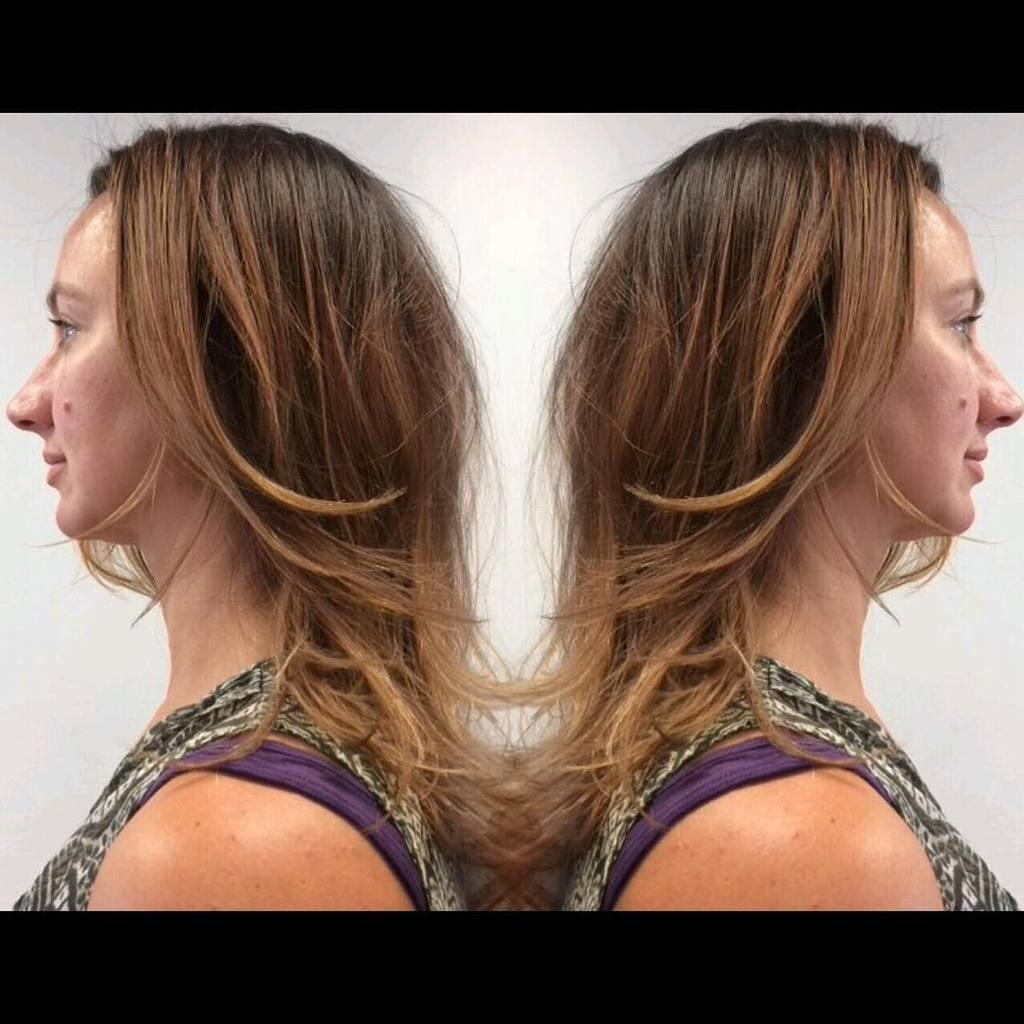How many women are in the image? There are two women in the image. What colors are the dresses worn by the women? The women are wearing black and purple color dresses. Do the women in the image resemble each other? Yes, the women look alike. What type of produce can be seen in the background of the image? There is no produce visible in the image; it only features two women wearing black and purple dresses. 